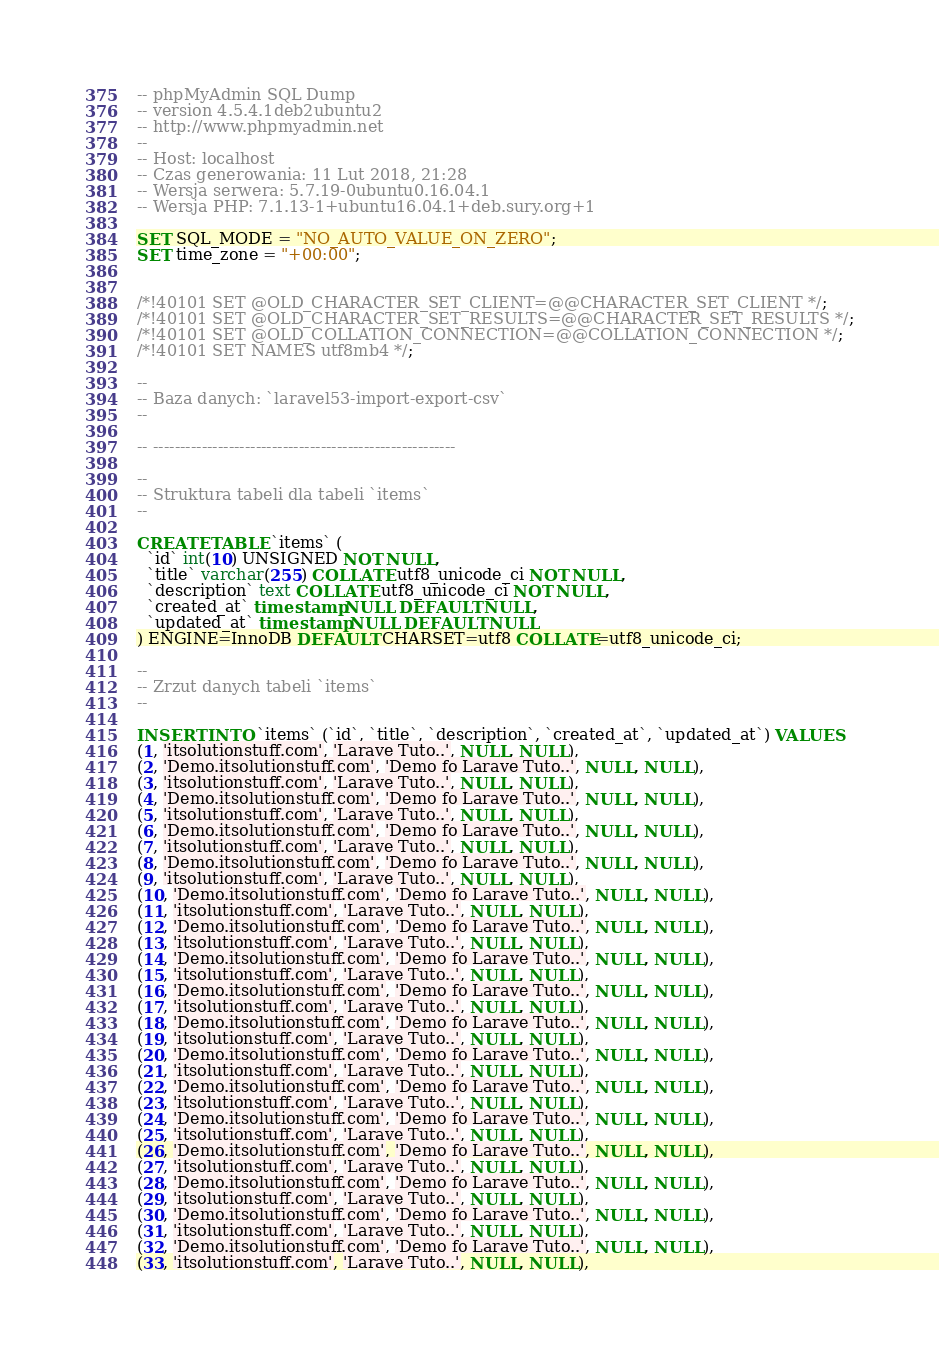<code> <loc_0><loc_0><loc_500><loc_500><_SQL_>-- phpMyAdmin SQL Dump
-- version 4.5.4.1deb2ubuntu2
-- http://www.phpmyadmin.net
--
-- Host: localhost
-- Czas generowania: 11 Lut 2018, 21:28
-- Wersja serwera: 5.7.19-0ubuntu0.16.04.1
-- Wersja PHP: 7.1.13-1+ubuntu16.04.1+deb.sury.org+1

SET SQL_MODE = "NO_AUTO_VALUE_ON_ZERO";
SET time_zone = "+00:00";


/*!40101 SET @OLD_CHARACTER_SET_CLIENT=@@CHARACTER_SET_CLIENT */;
/*!40101 SET @OLD_CHARACTER_SET_RESULTS=@@CHARACTER_SET_RESULTS */;
/*!40101 SET @OLD_COLLATION_CONNECTION=@@COLLATION_CONNECTION */;
/*!40101 SET NAMES utf8mb4 */;

--
-- Baza danych: `laravel53-import-export-csv`
--

-- --------------------------------------------------------

--
-- Struktura tabeli dla tabeli `items`
--

CREATE TABLE `items` (
  `id` int(10) UNSIGNED NOT NULL,
  `title` varchar(255) COLLATE utf8_unicode_ci NOT NULL,
  `description` text COLLATE utf8_unicode_ci NOT NULL,
  `created_at` timestamp NULL DEFAULT NULL,
  `updated_at` timestamp NULL DEFAULT NULL
) ENGINE=InnoDB DEFAULT CHARSET=utf8 COLLATE=utf8_unicode_ci;

--
-- Zrzut danych tabeli `items`
--

INSERT INTO `items` (`id`, `title`, `description`, `created_at`, `updated_at`) VALUES
(1, 'itsolutionstuff.com', 'Larave Tuto..', NULL, NULL),
(2, 'Demo.itsolutionstuff.com', 'Demo fo Larave Tuto..', NULL, NULL),
(3, 'itsolutionstuff.com', 'Larave Tuto..', NULL, NULL),
(4, 'Demo.itsolutionstuff.com', 'Demo fo Larave Tuto..', NULL, NULL),
(5, 'itsolutionstuff.com', 'Larave Tuto..', NULL, NULL),
(6, 'Demo.itsolutionstuff.com', 'Demo fo Larave Tuto..', NULL, NULL),
(7, 'itsolutionstuff.com', 'Larave Tuto..', NULL, NULL),
(8, 'Demo.itsolutionstuff.com', 'Demo fo Larave Tuto..', NULL, NULL),
(9, 'itsolutionstuff.com', 'Larave Tuto..', NULL, NULL),
(10, 'Demo.itsolutionstuff.com', 'Demo fo Larave Tuto..', NULL, NULL),
(11, 'itsolutionstuff.com', 'Larave Tuto..', NULL, NULL),
(12, 'Demo.itsolutionstuff.com', 'Demo fo Larave Tuto..', NULL, NULL),
(13, 'itsolutionstuff.com', 'Larave Tuto..', NULL, NULL),
(14, 'Demo.itsolutionstuff.com', 'Demo fo Larave Tuto..', NULL, NULL),
(15, 'itsolutionstuff.com', 'Larave Tuto..', NULL, NULL),
(16, 'Demo.itsolutionstuff.com', 'Demo fo Larave Tuto..', NULL, NULL),
(17, 'itsolutionstuff.com', 'Larave Tuto..', NULL, NULL),
(18, 'Demo.itsolutionstuff.com', 'Demo fo Larave Tuto..', NULL, NULL),
(19, 'itsolutionstuff.com', 'Larave Tuto..', NULL, NULL),
(20, 'Demo.itsolutionstuff.com', 'Demo fo Larave Tuto..', NULL, NULL),
(21, 'itsolutionstuff.com', 'Larave Tuto..', NULL, NULL),
(22, 'Demo.itsolutionstuff.com', 'Demo fo Larave Tuto..', NULL, NULL),
(23, 'itsolutionstuff.com', 'Larave Tuto..', NULL, NULL),
(24, 'Demo.itsolutionstuff.com', 'Demo fo Larave Tuto..', NULL, NULL),
(25, 'itsolutionstuff.com', 'Larave Tuto..', NULL, NULL),
(26, 'Demo.itsolutionstuff.com', 'Demo fo Larave Tuto..', NULL, NULL),
(27, 'itsolutionstuff.com', 'Larave Tuto..', NULL, NULL),
(28, 'Demo.itsolutionstuff.com', 'Demo fo Larave Tuto..', NULL, NULL),
(29, 'itsolutionstuff.com', 'Larave Tuto..', NULL, NULL),
(30, 'Demo.itsolutionstuff.com', 'Demo fo Larave Tuto..', NULL, NULL),
(31, 'itsolutionstuff.com', 'Larave Tuto..', NULL, NULL),
(32, 'Demo.itsolutionstuff.com', 'Demo fo Larave Tuto..', NULL, NULL),
(33, 'itsolutionstuff.com', 'Larave Tuto..', NULL, NULL),</code> 